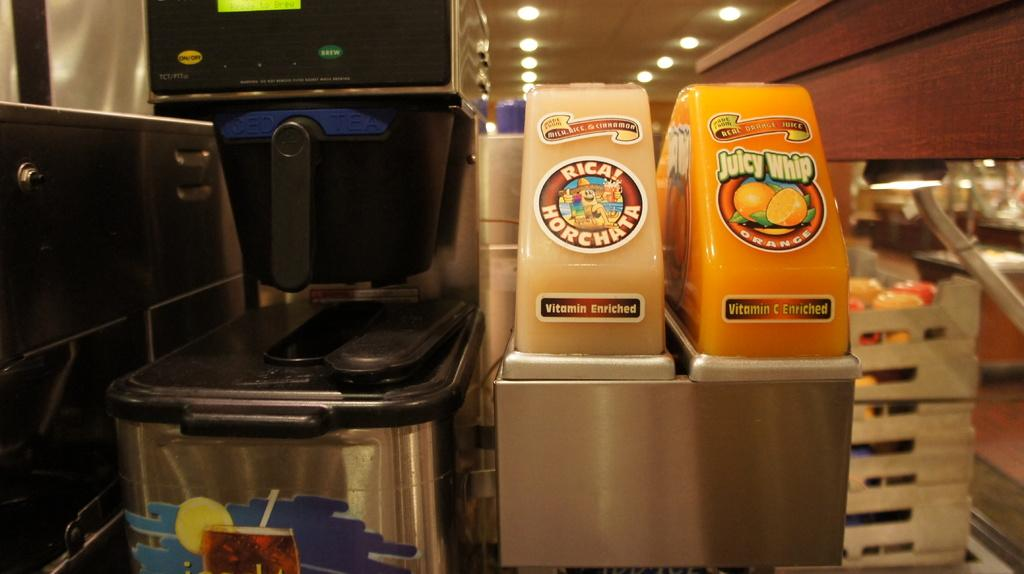<image>
Provide a brief description of the given image. a drink machine offering rical horchata and juicy whip orange, both enriched with vitamin c 